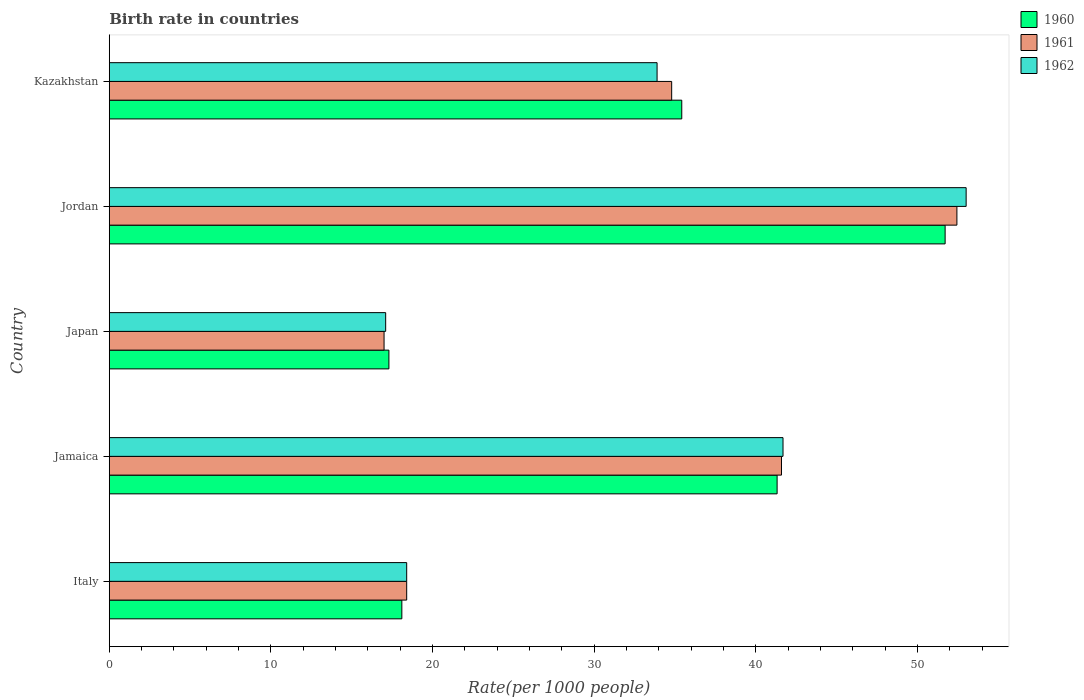How many groups of bars are there?
Keep it short and to the point. 5. Are the number of bars per tick equal to the number of legend labels?
Your answer should be very brief. Yes. What is the label of the 2nd group of bars from the top?
Offer a very short reply. Jordan. In how many cases, is the number of bars for a given country not equal to the number of legend labels?
Make the answer very short. 0. What is the birth rate in 1962 in Jordan?
Ensure brevity in your answer.  53.01. Across all countries, what is the maximum birth rate in 1962?
Your response must be concise. 53.01. In which country was the birth rate in 1961 maximum?
Your response must be concise. Jordan. In which country was the birth rate in 1962 minimum?
Your response must be concise. Japan. What is the total birth rate in 1961 in the graph?
Your answer should be compact. 164.22. What is the difference between the birth rate in 1960 in Italy and that in Jordan?
Provide a succinct answer. -33.61. What is the difference between the birth rate in 1961 in Jordan and the birth rate in 1960 in Kazakhstan?
Provide a succinct answer. 17.02. What is the average birth rate in 1960 per country?
Provide a succinct answer. 32.77. What is the difference between the birth rate in 1960 and birth rate in 1961 in Japan?
Provide a short and direct response. 0.3. In how many countries, is the birth rate in 1961 greater than 2 ?
Your response must be concise. 5. What is the ratio of the birth rate in 1962 in Jamaica to that in Kazakhstan?
Your answer should be very brief. 1.23. Is the difference between the birth rate in 1960 in Jordan and Kazakhstan greater than the difference between the birth rate in 1961 in Jordan and Kazakhstan?
Ensure brevity in your answer.  No. What is the difference between the highest and the second highest birth rate in 1961?
Your response must be concise. 10.85. What is the difference between the highest and the lowest birth rate in 1961?
Your response must be concise. 35.44. In how many countries, is the birth rate in 1962 greater than the average birth rate in 1962 taken over all countries?
Offer a very short reply. 3. What does the 1st bar from the bottom in Japan represents?
Your response must be concise. 1960. How many bars are there?
Provide a succinct answer. 15. How many countries are there in the graph?
Your answer should be compact. 5. What is the difference between two consecutive major ticks on the X-axis?
Keep it short and to the point. 10. Where does the legend appear in the graph?
Offer a terse response. Top right. How are the legend labels stacked?
Your answer should be very brief. Vertical. What is the title of the graph?
Your answer should be compact. Birth rate in countries. Does "1989" appear as one of the legend labels in the graph?
Offer a very short reply. No. What is the label or title of the X-axis?
Keep it short and to the point. Rate(per 1000 people). What is the label or title of the Y-axis?
Give a very brief answer. Country. What is the Rate(per 1000 people) in 1961 in Italy?
Give a very brief answer. 18.4. What is the Rate(per 1000 people) of 1960 in Jamaica?
Offer a terse response. 41.32. What is the Rate(per 1000 people) of 1961 in Jamaica?
Offer a very short reply. 41.59. What is the Rate(per 1000 people) of 1962 in Jamaica?
Offer a terse response. 41.68. What is the Rate(per 1000 people) of 1960 in Jordan?
Make the answer very short. 51.71. What is the Rate(per 1000 people) in 1961 in Jordan?
Your answer should be very brief. 52.44. What is the Rate(per 1000 people) of 1962 in Jordan?
Ensure brevity in your answer.  53.01. What is the Rate(per 1000 people) of 1960 in Kazakhstan?
Your response must be concise. 35.42. What is the Rate(per 1000 people) of 1961 in Kazakhstan?
Ensure brevity in your answer.  34.79. What is the Rate(per 1000 people) in 1962 in Kazakhstan?
Your answer should be compact. 33.89. Across all countries, what is the maximum Rate(per 1000 people) in 1960?
Your answer should be very brief. 51.71. Across all countries, what is the maximum Rate(per 1000 people) in 1961?
Your response must be concise. 52.44. Across all countries, what is the maximum Rate(per 1000 people) of 1962?
Your answer should be very brief. 53.01. Across all countries, what is the minimum Rate(per 1000 people) of 1961?
Provide a short and direct response. 17. Across all countries, what is the minimum Rate(per 1000 people) of 1962?
Provide a succinct answer. 17.1. What is the total Rate(per 1000 people) in 1960 in the graph?
Offer a very short reply. 163.84. What is the total Rate(per 1000 people) of 1961 in the graph?
Provide a short and direct response. 164.22. What is the total Rate(per 1000 people) of 1962 in the graph?
Offer a terse response. 164.08. What is the difference between the Rate(per 1000 people) of 1960 in Italy and that in Jamaica?
Provide a succinct answer. -23.22. What is the difference between the Rate(per 1000 people) of 1961 in Italy and that in Jamaica?
Provide a short and direct response. -23.19. What is the difference between the Rate(per 1000 people) of 1962 in Italy and that in Jamaica?
Your answer should be compact. -23.28. What is the difference between the Rate(per 1000 people) of 1961 in Italy and that in Japan?
Keep it short and to the point. 1.4. What is the difference between the Rate(per 1000 people) in 1960 in Italy and that in Jordan?
Offer a very short reply. -33.61. What is the difference between the Rate(per 1000 people) of 1961 in Italy and that in Jordan?
Provide a short and direct response. -34.04. What is the difference between the Rate(per 1000 people) in 1962 in Italy and that in Jordan?
Your answer should be very brief. -34.61. What is the difference between the Rate(per 1000 people) of 1960 in Italy and that in Kazakhstan?
Offer a terse response. -17.32. What is the difference between the Rate(per 1000 people) in 1961 in Italy and that in Kazakhstan?
Your answer should be very brief. -16.39. What is the difference between the Rate(per 1000 people) in 1962 in Italy and that in Kazakhstan?
Your answer should be compact. -15.49. What is the difference between the Rate(per 1000 people) in 1960 in Jamaica and that in Japan?
Make the answer very short. 24.02. What is the difference between the Rate(per 1000 people) of 1961 in Jamaica and that in Japan?
Make the answer very short. 24.59. What is the difference between the Rate(per 1000 people) of 1962 in Jamaica and that in Japan?
Provide a short and direct response. 24.58. What is the difference between the Rate(per 1000 people) of 1960 in Jamaica and that in Jordan?
Your answer should be very brief. -10.39. What is the difference between the Rate(per 1000 people) in 1961 in Jamaica and that in Jordan?
Offer a terse response. -10.85. What is the difference between the Rate(per 1000 people) of 1962 in Jamaica and that in Jordan?
Provide a succinct answer. -11.33. What is the difference between the Rate(per 1000 people) of 1960 in Jamaica and that in Kazakhstan?
Make the answer very short. 5.9. What is the difference between the Rate(per 1000 people) in 1961 in Jamaica and that in Kazakhstan?
Make the answer very short. 6.79. What is the difference between the Rate(per 1000 people) in 1962 in Jamaica and that in Kazakhstan?
Ensure brevity in your answer.  7.79. What is the difference between the Rate(per 1000 people) of 1960 in Japan and that in Jordan?
Keep it short and to the point. -34.41. What is the difference between the Rate(per 1000 people) of 1961 in Japan and that in Jordan?
Give a very brief answer. -35.44. What is the difference between the Rate(per 1000 people) in 1962 in Japan and that in Jordan?
Your answer should be compact. -35.91. What is the difference between the Rate(per 1000 people) of 1960 in Japan and that in Kazakhstan?
Provide a succinct answer. -18.12. What is the difference between the Rate(per 1000 people) in 1961 in Japan and that in Kazakhstan?
Your answer should be very brief. -17.79. What is the difference between the Rate(per 1000 people) of 1962 in Japan and that in Kazakhstan?
Your answer should be very brief. -16.79. What is the difference between the Rate(per 1000 people) of 1960 in Jordan and that in Kazakhstan?
Give a very brief answer. 16.29. What is the difference between the Rate(per 1000 people) in 1961 in Jordan and that in Kazakhstan?
Offer a terse response. 17.65. What is the difference between the Rate(per 1000 people) of 1962 in Jordan and that in Kazakhstan?
Your answer should be very brief. 19.12. What is the difference between the Rate(per 1000 people) of 1960 in Italy and the Rate(per 1000 people) of 1961 in Jamaica?
Provide a succinct answer. -23.49. What is the difference between the Rate(per 1000 people) in 1960 in Italy and the Rate(per 1000 people) in 1962 in Jamaica?
Offer a very short reply. -23.58. What is the difference between the Rate(per 1000 people) of 1961 in Italy and the Rate(per 1000 people) of 1962 in Jamaica?
Offer a very short reply. -23.28. What is the difference between the Rate(per 1000 people) in 1960 in Italy and the Rate(per 1000 people) in 1961 in Japan?
Keep it short and to the point. 1.1. What is the difference between the Rate(per 1000 people) of 1960 in Italy and the Rate(per 1000 people) of 1962 in Japan?
Your answer should be very brief. 1. What is the difference between the Rate(per 1000 people) of 1960 in Italy and the Rate(per 1000 people) of 1961 in Jordan?
Offer a terse response. -34.34. What is the difference between the Rate(per 1000 people) of 1960 in Italy and the Rate(per 1000 people) of 1962 in Jordan?
Provide a short and direct response. -34.91. What is the difference between the Rate(per 1000 people) in 1961 in Italy and the Rate(per 1000 people) in 1962 in Jordan?
Ensure brevity in your answer.  -34.61. What is the difference between the Rate(per 1000 people) of 1960 in Italy and the Rate(per 1000 people) of 1961 in Kazakhstan?
Keep it short and to the point. -16.69. What is the difference between the Rate(per 1000 people) in 1960 in Italy and the Rate(per 1000 people) in 1962 in Kazakhstan?
Offer a very short reply. -15.79. What is the difference between the Rate(per 1000 people) of 1961 in Italy and the Rate(per 1000 people) of 1962 in Kazakhstan?
Provide a short and direct response. -15.49. What is the difference between the Rate(per 1000 people) of 1960 in Jamaica and the Rate(per 1000 people) of 1961 in Japan?
Make the answer very short. 24.32. What is the difference between the Rate(per 1000 people) of 1960 in Jamaica and the Rate(per 1000 people) of 1962 in Japan?
Your response must be concise. 24.22. What is the difference between the Rate(per 1000 people) of 1961 in Jamaica and the Rate(per 1000 people) of 1962 in Japan?
Offer a very short reply. 24.49. What is the difference between the Rate(per 1000 people) in 1960 in Jamaica and the Rate(per 1000 people) in 1961 in Jordan?
Provide a short and direct response. -11.12. What is the difference between the Rate(per 1000 people) of 1960 in Jamaica and the Rate(per 1000 people) of 1962 in Jordan?
Give a very brief answer. -11.7. What is the difference between the Rate(per 1000 people) in 1961 in Jamaica and the Rate(per 1000 people) in 1962 in Jordan?
Ensure brevity in your answer.  -11.42. What is the difference between the Rate(per 1000 people) in 1960 in Jamaica and the Rate(per 1000 people) in 1961 in Kazakhstan?
Provide a short and direct response. 6.52. What is the difference between the Rate(per 1000 people) in 1960 in Jamaica and the Rate(per 1000 people) in 1962 in Kazakhstan?
Keep it short and to the point. 7.43. What is the difference between the Rate(per 1000 people) of 1961 in Jamaica and the Rate(per 1000 people) of 1962 in Kazakhstan?
Keep it short and to the point. 7.7. What is the difference between the Rate(per 1000 people) of 1960 in Japan and the Rate(per 1000 people) of 1961 in Jordan?
Give a very brief answer. -35.14. What is the difference between the Rate(per 1000 people) of 1960 in Japan and the Rate(per 1000 people) of 1962 in Jordan?
Make the answer very short. -35.71. What is the difference between the Rate(per 1000 people) in 1961 in Japan and the Rate(per 1000 people) in 1962 in Jordan?
Ensure brevity in your answer.  -36.01. What is the difference between the Rate(per 1000 people) of 1960 in Japan and the Rate(per 1000 people) of 1961 in Kazakhstan?
Make the answer very short. -17.49. What is the difference between the Rate(per 1000 people) in 1960 in Japan and the Rate(per 1000 people) in 1962 in Kazakhstan?
Ensure brevity in your answer.  -16.59. What is the difference between the Rate(per 1000 people) in 1961 in Japan and the Rate(per 1000 people) in 1962 in Kazakhstan?
Ensure brevity in your answer.  -16.89. What is the difference between the Rate(per 1000 people) of 1960 in Jordan and the Rate(per 1000 people) of 1961 in Kazakhstan?
Your answer should be compact. 16.92. What is the difference between the Rate(per 1000 people) of 1960 in Jordan and the Rate(per 1000 people) of 1962 in Kazakhstan?
Your response must be concise. 17.82. What is the difference between the Rate(per 1000 people) of 1961 in Jordan and the Rate(per 1000 people) of 1962 in Kazakhstan?
Give a very brief answer. 18.55. What is the average Rate(per 1000 people) of 1960 per country?
Provide a short and direct response. 32.77. What is the average Rate(per 1000 people) in 1961 per country?
Make the answer very short. 32.84. What is the average Rate(per 1000 people) of 1962 per country?
Provide a succinct answer. 32.82. What is the difference between the Rate(per 1000 people) of 1961 and Rate(per 1000 people) of 1962 in Italy?
Offer a terse response. 0. What is the difference between the Rate(per 1000 people) in 1960 and Rate(per 1000 people) in 1961 in Jamaica?
Your answer should be very brief. -0.27. What is the difference between the Rate(per 1000 people) in 1960 and Rate(per 1000 people) in 1962 in Jamaica?
Offer a terse response. -0.36. What is the difference between the Rate(per 1000 people) of 1961 and Rate(per 1000 people) of 1962 in Jamaica?
Your answer should be very brief. -0.09. What is the difference between the Rate(per 1000 people) of 1960 and Rate(per 1000 people) of 1961 in Japan?
Offer a very short reply. 0.3. What is the difference between the Rate(per 1000 people) of 1960 and Rate(per 1000 people) of 1962 in Japan?
Ensure brevity in your answer.  0.2. What is the difference between the Rate(per 1000 people) in 1961 and Rate(per 1000 people) in 1962 in Japan?
Ensure brevity in your answer.  -0.1. What is the difference between the Rate(per 1000 people) in 1960 and Rate(per 1000 people) in 1961 in Jordan?
Provide a succinct answer. -0.73. What is the difference between the Rate(per 1000 people) of 1960 and Rate(per 1000 people) of 1962 in Jordan?
Make the answer very short. -1.3. What is the difference between the Rate(per 1000 people) in 1961 and Rate(per 1000 people) in 1962 in Jordan?
Provide a short and direct response. -0.57. What is the difference between the Rate(per 1000 people) of 1960 and Rate(per 1000 people) of 1961 in Kazakhstan?
Provide a short and direct response. 0.62. What is the difference between the Rate(per 1000 people) in 1960 and Rate(per 1000 people) in 1962 in Kazakhstan?
Provide a succinct answer. 1.53. What is the difference between the Rate(per 1000 people) of 1961 and Rate(per 1000 people) of 1962 in Kazakhstan?
Provide a succinct answer. 0.9. What is the ratio of the Rate(per 1000 people) in 1960 in Italy to that in Jamaica?
Your answer should be very brief. 0.44. What is the ratio of the Rate(per 1000 people) in 1961 in Italy to that in Jamaica?
Offer a very short reply. 0.44. What is the ratio of the Rate(per 1000 people) in 1962 in Italy to that in Jamaica?
Ensure brevity in your answer.  0.44. What is the ratio of the Rate(per 1000 people) in 1960 in Italy to that in Japan?
Provide a short and direct response. 1.05. What is the ratio of the Rate(per 1000 people) of 1961 in Italy to that in Japan?
Your answer should be compact. 1.08. What is the ratio of the Rate(per 1000 people) of 1962 in Italy to that in Japan?
Provide a short and direct response. 1.08. What is the ratio of the Rate(per 1000 people) in 1960 in Italy to that in Jordan?
Offer a very short reply. 0.35. What is the ratio of the Rate(per 1000 people) of 1961 in Italy to that in Jordan?
Provide a short and direct response. 0.35. What is the ratio of the Rate(per 1000 people) of 1962 in Italy to that in Jordan?
Your answer should be very brief. 0.35. What is the ratio of the Rate(per 1000 people) in 1960 in Italy to that in Kazakhstan?
Ensure brevity in your answer.  0.51. What is the ratio of the Rate(per 1000 people) of 1961 in Italy to that in Kazakhstan?
Keep it short and to the point. 0.53. What is the ratio of the Rate(per 1000 people) in 1962 in Italy to that in Kazakhstan?
Offer a very short reply. 0.54. What is the ratio of the Rate(per 1000 people) in 1960 in Jamaica to that in Japan?
Give a very brief answer. 2.39. What is the ratio of the Rate(per 1000 people) in 1961 in Jamaica to that in Japan?
Make the answer very short. 2.45. What is the ratio of the Rate(per 1000 people) of 1962 in Jamaica to that in Japan?
Provide a succinct answer. 2.44. What is the ratio of the Rate(per 1000 people) in 1960 in Jamaica to that in Jordan?
Provide a short and direct response. 0.8. What is the ratio of the Rate(per 1000 people) of 1961 in Jamaica to that in Jordan?
Your answer should be compact. 0.79. What is the ratio of the Rate(per 1000 people) of 1962 in Jamaica to that in Jordan?
Your answer should be compact. 0.79. What is the ratio of the Rate(per 1000 people) in 1960 in Jamaica to that in Kazakhstan?
Provide a short and direct response. 1.17. What is the ratio of the Rate(per 1000 people) of 1961 in Jamaica to that in Kazakhstan?
Keep it short and to the point. 1.2. What is the ratio of the Rate(per 1000 people) of 1962 in Jamaica to that in Kazakhstan?
Your answer should be very brief. 1.23. What is the ratio of the Rate(per 1000 people) of 1960 in Japan to that in Jordan?
Provide a succinct answer. 0.33. What is the ratio of the Rate(per 1000 people) in 1961 in Japan to that in Jordan?
Your answer should be compact. 0.32. What is the ratio of the Rate(per 1000 people) in 1962 in Japan to that in Jordan?
Keep it short and to the point. 0.32. What is the ratio of the Rate(per 1000 people) in 1960 in Japan to that in Kazakhstan?
Your response must be concise. 0.49. What is the ratio of the Rate(per 1000 people) of 1961 in Japan to that in Kazakhstan?
Make the answer very short. 0.49. What is the ratio of the Rate(per 1000 people) in 1962 in Japan to that in Kazakhstan?
Ensure brevity in your answer.  0.5. What is the ratio of the Rate(per 1000 people) in 1960 in Jordan to that in Kazakhstan?
Ensure brevity in your answer.  1.46. What is the ratio of the Rate(per 1000 people) in 1961 in Jordan to that in Kazakhstan?
Give a very brief answer. 1.51. What is the ratio of the Rate(per 1000 people) in 1962 in Jordan to that in Kazakhstan?
Ensure brevity in your answer.  1.56. What is the difference between the highest and the second highest Rate(per 1000 people) of 1960?
Ensure brevity in your answer.  10.39. What is the difference between the highest and the second highest Rate(per 1000 people) of 1961?
Provide a short and direct response. 10.85. What is the difference between the highest and the second highest Rate(per 1000 people) of 1962?
Make the answer very short. 11.33. What is the difference between the highest and the lowest Rate(per 1000 people) of 1960?
Offer a very short reply. 34.41. What is the difference between the highest and the lowest Rate(per 1000 people) of 1961?
Offer a terse response. 35.44. What is the difference between the highest and the lowest Rate(per 1000 people) of 1962?
Offer a very short reply. 35.91. 